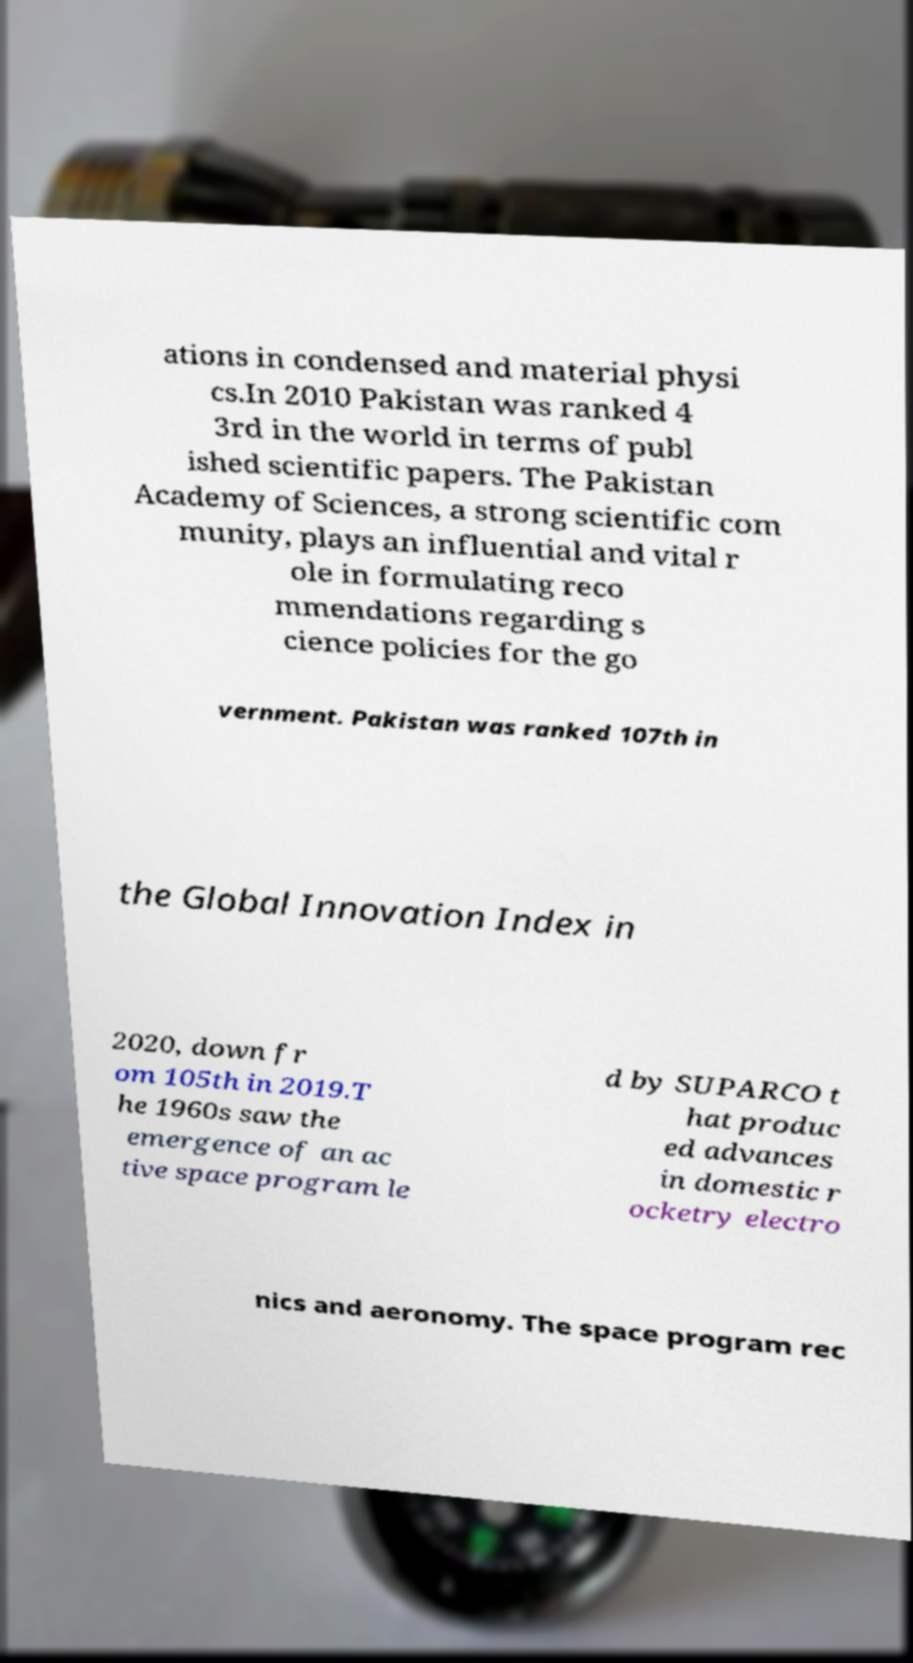For documentation purposes, I need the text within this image transcribed. Could you provide that? ations in condensed and material physi cs.In 2010 Pakistan was ranked 4 3rd in the world in terms of publ ished scientific papers. The Pakistan Academy of Sciences, a strong scientific com munity, plays an influential and vital r ole in formulating reco mmendations regarding s cience policies for the go vernment. Pakistan was ranked 107th in the Global Innovation Index in 2020, down fr om 105th in 2019.T he 1960s saw the emergence of an ac tive space program le d by SUPARCO t hat produc ed advances in domestic r ocketry electro nics and aeronomy. The space program rec 